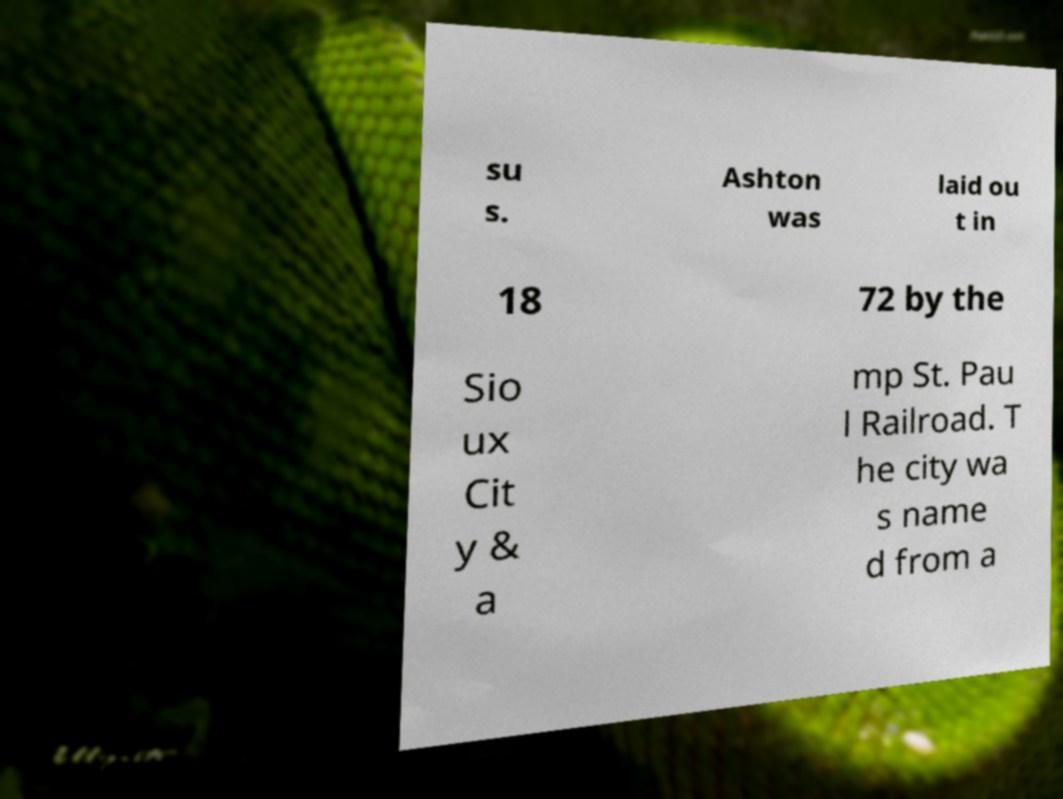For documentation purposes, I need the text within this image transcribed. Could you provide that? su s. Ashton was laid ou t in 18 72 by the Sio ux Cit y & a mp St. Pau l Railroad. T he city wa s name d from a 